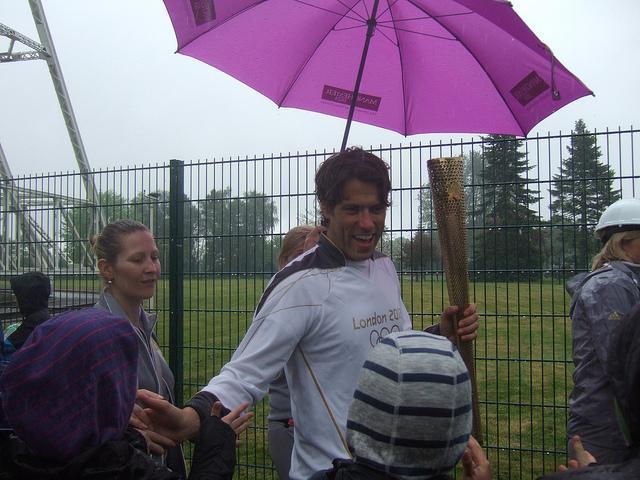How many people are visible?
Give a very brief answer. 7. 